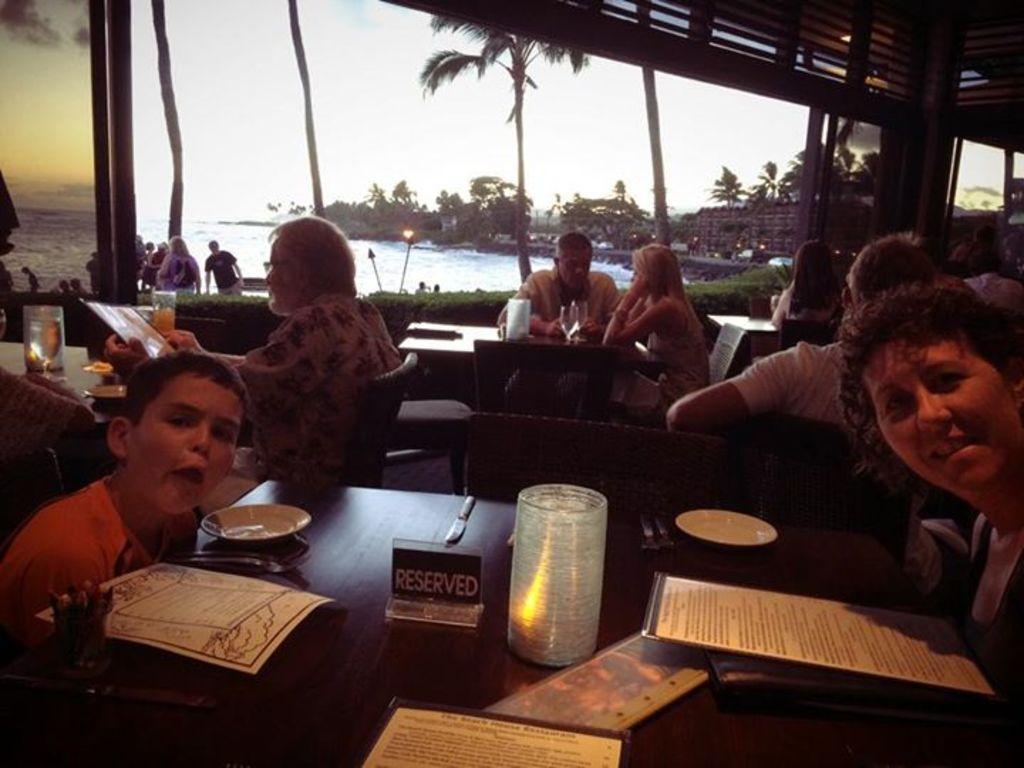In one or two sentences, can you explain what this image depicts? In this picture I can see group of people sitting on the chairs, there are cards, plates and some other objects on the tables, through the window, I can see water, trees and the sky. 